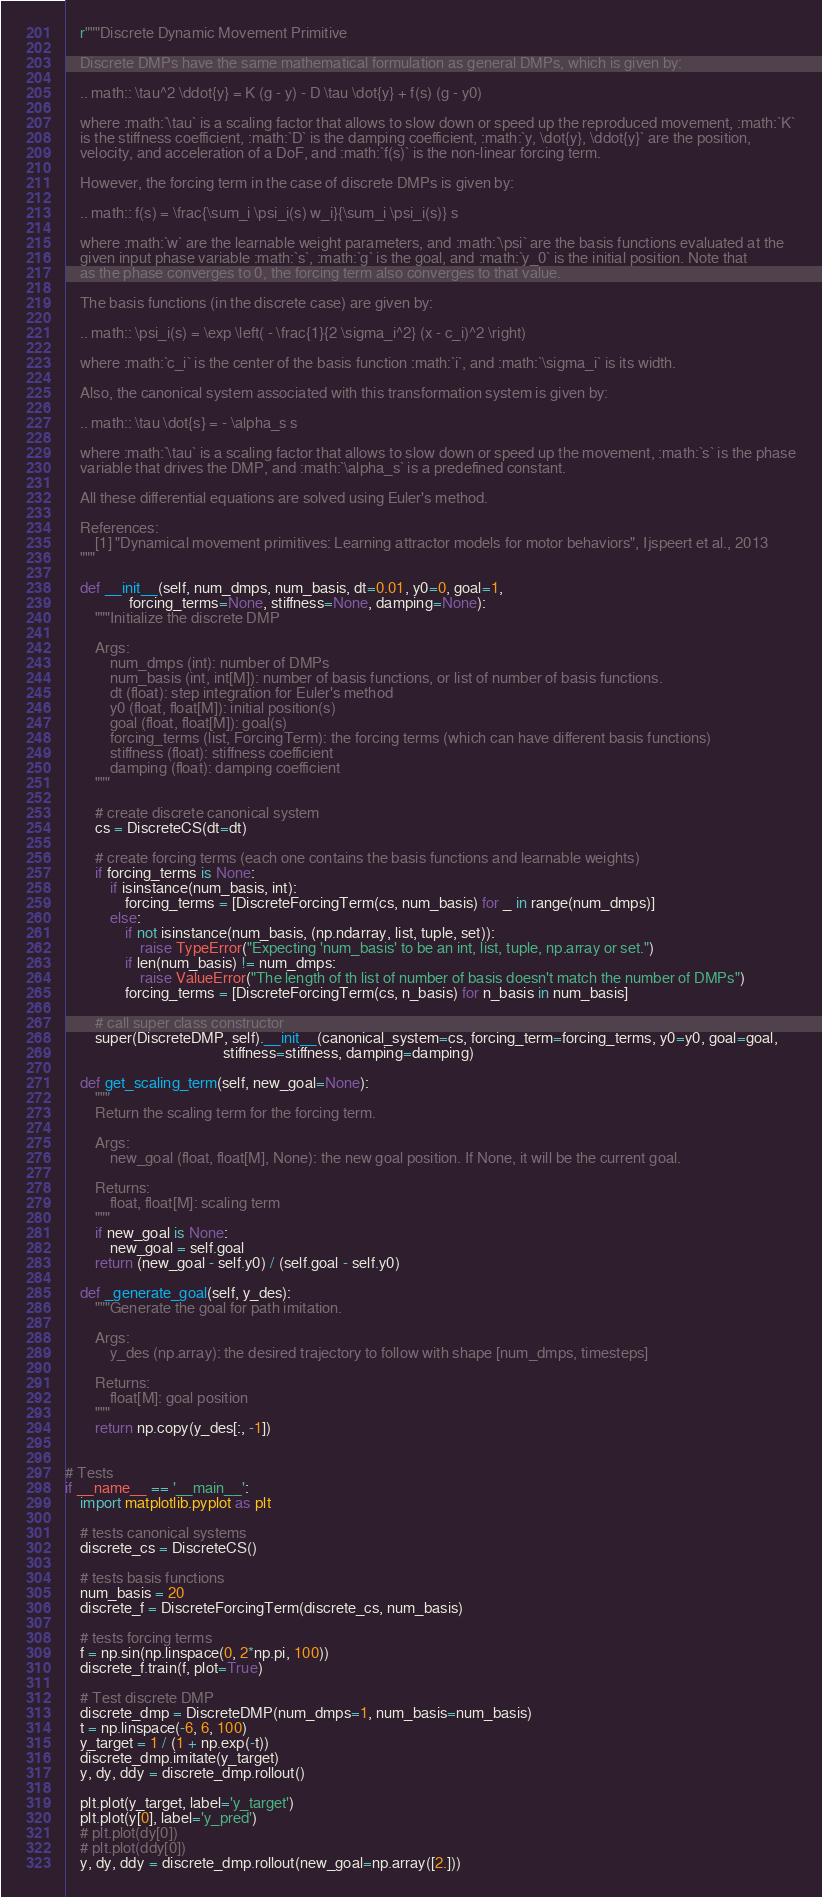<code> <loc_0><loc_0><loc_500><loc_500><_Python_>    r"""Discrete Dynamic Movement Primitive

    Discrete DMPs have the same mathematical formulation as general DMPs, which is given by:

    .. math:: \tau^2 \ddot{y} = K (g - y) - D \tau \dot{y} + f(s) (g - y0)

    where :math:`\tau` is a scaling factor that allows to slow down or speed up the reproduced movement, :math:`K`
    is the stiffness coefficient, :math:`D` is the damping coefficient, :math:`y, \dot{y}, \ddot{y}` are the position,
    velocity, and acceleration of a DoF, and :math:`f(s)` is the non-linear forcing term.

    However, the forcing term in the case of discrete DMPs is given by:

    .. math:: f(s) = \frac{\sum_i \psi_i(s) w_i}{\sum_i \psi_i(s)} s

    where :math:`w` are the learnable weight parameters, and :math:`\psi` are the basis functions evaluated at the
    given input phase variable :math:`s`, :math:`g` is the goal, and :math:`y_0` is the initial position. Note that
    as the phase converges to 0, the forcing term also converges to that value.

    The basis functions (in the discrete case) are given by:

    .. math:: \psi_i(s) = \exp \left( - \frac{1}{2 \sigma_i^2} (x - c_i)^2 \right)

    where :math:`c_i` is the center of the basis function :math:`i`, and :math:`\sigma_i` is its width.

    Also, the canonical system associated with this transformation system is given by:

    .. math:: \tau \dot{s} = - \alpha_s s

    where :math:`\tau` is a scaling factor that allows to slow down or speed up the movement, :math:`s` is the phase
    variable that drives the DMP, and :math:`\alpha_s` is a predefined constant.

    All these differential equations are solved using Euler's method.

    References:
        [1] "Dynamical movement primitives: Learning attractor models for motor behaviors", Ijspeert et al., 2013
    """

    def __init__(self, num_dmps, num_basis, dt=0.01, y0=0, goal=1,
                 forcing_terms=None, stiffness=None, damping=None):
        """Initialize the discrete DMP

        Args:
            num_dmps (int): number of DMPs
            num_basis (int, int[M]): number of basis functions, or list of number of basis functions.
            dt (float): step integration for Euler's method
            y0 (float, float[M]): initial position(s)
            goal (float, float[M]): goal(s)
            forcing_terms (list, ForcingTerm): the forcing terms (which can have different basis functions)
            stiffness (float): stiffness coefficient
            damping (float): damping coefficient
        """

        # create discrete canonical system
        cs = DiscreteCS(dt=dt)

        # create forcing terms (each one contains the basis functions and learnable weights)
        if forcing_terms is None:
            if isinstance(num_basis, int):
                forcing_terms = [DiscreteForcingTerm(cs, num_basis) for _ in range(num_dmps)]
            else:
                if not isinstance(num_basis, (np.ndarray, list, tuple, set)):
                    raise TypeError("Expecting 'num_basis' to be an int, list, tuple, np.array or set.")
                if len(num_basis) != num_dmps:
                    raise ValueError("The length of th list of number of basis doesn't match the number of DMPs")
                forcing_terms = [DiscreteForcingTerm(cs, n_basis) for n_basis in num_basis]

        # call super class constructor
        super(DiscreteDMP, self).__init__(canonical_system=cs, forcing_term=forcing_terms, y0=y0, goal=goal,
                                          stiffness=stiffness, damping=damping)

    def get_scaling_term(self, new_goal=None):
        """
        Return the scaling term for the forcing term.

        Args:
            new_goal (float, float[M], None): the new goal position. If None, it will be the current goal.

        Returns:
            float, float[M]: scaling term
        """
        if new_goal is None:
            new_goal = self.goal
        return (new_goal - self.y0) / (self.goal - self.y0)

    def _generate_goal(self, y_des):
        """Generate the goal for path imitation.

        Args:
            y_des (np.array): the desired trajectory to follow with shape [num_dmps, timesteps]

        Returns:
            float[M]: goal position
        """
        return np.copy(y_des[:, -1])


# Tests
if __name__ == '__main__':
    import matplotlib.pyplot as plt

    # tests canonical systems
    discrete_cs = DiscreteCS()

    # tests basis functions
    num_basis = 20
    discrete_f = DiscreteForcingTerm(discrete_cs, num_basis)

    # tests forcing terms
    f = np.sin(np.linspace(0, 2*np.pi, 100))
    discrete_f.train(f, plot=True)

    # Test discrete DMP
    discrete_dmp = DiscreteDMP(num_dmps=1, num_basis=num_basis)
    t = np.linspace(-6, 6, 100)
    y_target = 1 / (1 + np.exp(-t))
    discrete_dmp.imitate(y_target)
    y, dy, ddy = discrete_dmp.rollout()

    plt.plot(y_target, label='y_target')
    plt.plot(y[0], label='y_pred')
    # plt.plot(dy[0])
    # plt.plot(ddy[0])
    y, dy, ddy = discrete_dmp.rollout(new_goal=np.array([2.]))</code> 